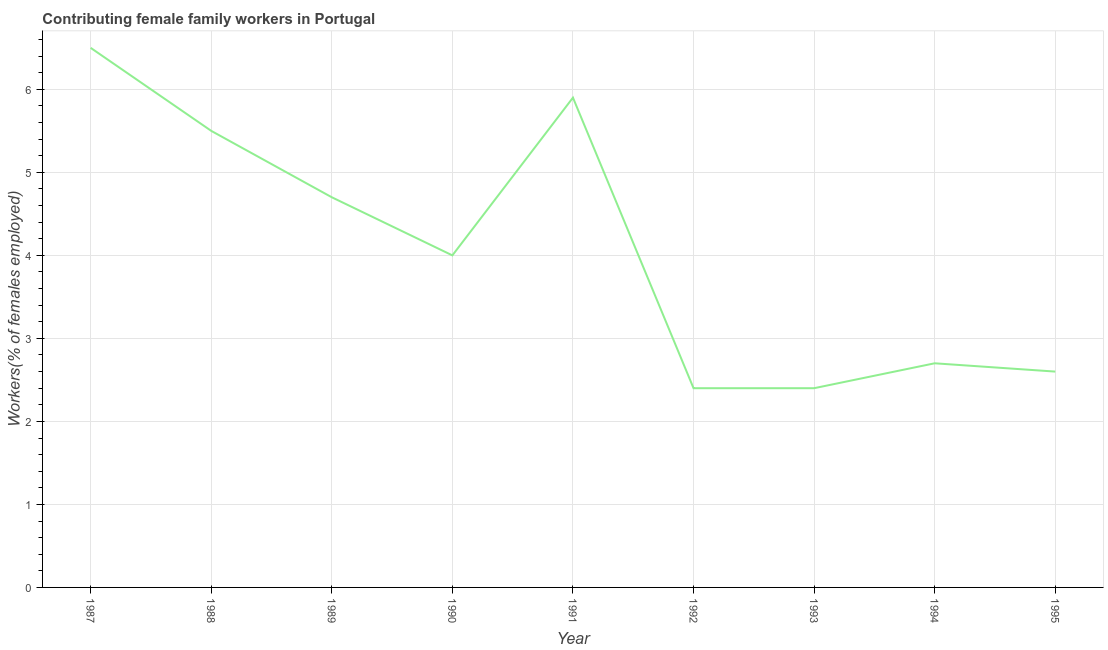What is the contributing female family workers in 1994?
Make the answer very short. 2.7. Across all years, what is the maximum contributing female family workers?
Provide a short and direct response. 6.5. Across all years, what is the minimum contributing female family workers?
Offer a very short reply. 2.4. What is the sum of the contributing female family workers?
Your response must be concise. 36.7. What is the difference between the contributing female family workers in 1987 and 1989?
Offer a very short reply. 1.8. What is the average contributing female family workers per year?
Give a very brief answer. 4.08. Do a majority of the years between 1987 and 1992 (inclusive) have contributing female family workers greater than 2.8 %?
Provide a short and direct response. Yes. What is the ratio of the contributing female family workers in 1990 to that in 1991?
Keep it short and to the point. 0.68. Is the contributing female family workers in 1994 less than that in 1995?
Make the answer very short. No. Is the difference between the contributing female family workers in 1989 and 1990 greater than the difference between any two years?
Your response must be concise. No. What is the difference between the highest and the second highest contributing female family workers?
Your answer should be very brief. 0.6. Is the sum of the contributing female family workers in 1993 and 1994 greater than the maximum contributing female family workers across all years?
Your response must be concise. No. What is the difference between the highest and the lowest contributing female family workers?
Provide a succinct answer. 4.1. In how many years, is the contributing female family workers greater than the average contributing female family workers taken over all years?
Your answer should be compact. 4. Does the contributing female family workers monotonically increase over the years?
Provide a short and direct response. No. How many lines are there?
Your response must be concise. 1. How many years are there in the graph?
Provide a succinct answer. 9. Does the graph contain grids?
Make the answer very short. Yes. What is the title of the graph?
Your response must be concise. Contributing female family workers in Portugal. What is the label or title of the X-axis?
Offer a terse response. Year. What is the label or title of the Y-axis?
Give a very brief answer. Workers(% of females employed). What is the Workers(% of females employed) in 1987?
Offer a very short reply. 6.5. What is the Workers(% of females employed) in 1989?
Your response must be concise. 4.7. What is the Workers(% of females employed) of 1990?
Provide a short and direct response. 4. What is the Workers(% of females employed) of 1991?
Provide a short and direct response. 5.9. What is the Workers(% of females employed) in 1992?
Make the answer very short. 2.4. What is the Workers(% of females employed) in 1993?
Ensure brevity in your answer.  2.4. What is the Workers(% of females employed) in 1994?
Offer a terse response. 2.7. What is the Workers(% of females employed) of 1995?
Provide a succinct answer. 2.6. What is the difference between the Workers(% of females employed) in 1987 and 1988?
Your answer should be very brief. 1. What is the difference between the Workers(% of females employed) in 1987 and 1989?
Your answer should be very brief. 1.8. What is the difference between the Workers(% of females employed) in 1987 and 1990?
Your answer should be very brief. 2.5. What is the difference between the Workers(% of females employed) in 1987 and 1991?
Offer a very short reply. 0.6. What is the difference between the Workers(% of females employed) in 1987 and 1993?
Keep it short and to the point. 4.1. What is the difference between the Workers(% of females employed) in 1987 and 1995?
Offer a terse response. 3.9. What is the difference between the Workers(% of females employed) in 1988 and 1989?
Your response must be concise. 0.8. What is the difference between the Workers(% of females employed) in 1988 and 1992?
Make the answer very short. 3.1. What is the difference between the Workers(% of females employed) in 1988 and 1995?
Your answer should be compact. 2.9. What is the difference between the Workers(% of females employed) in 1989 and 1991?
Provide a succinct answer. -1.2. What is the difference between the Workers(% of females employed) in 1989 and 1993?
Give a very brief answer. 2.3. What is the difference between the Workers(% of females employed) in 1989 and 1995?
Your answer should be compact. 2.1. What is the difference between the Workers(% of females employed) in 1990 and 1991?
Your response must be concise. -1.9. What is the difference between the Workers(% of females employed) in 1990 and 1993?
Keep it short and to the point. 1.6. What is the difference between the Workers(% of females employed) in 1991 and 1995?
Give a very brief answer. 3.3. What is the difference between the Workers(% of females employed) in 1992 and 1994?
Keep it short and to the point. -0.3. What is the difference between the Workers(% of females employed) in 1993 and 1995?
Your answer should be very brief. -0.2. What is the ratio of the Workers(% of females employed) in 1987 to that in 1988?
Make the answer very short. 1.18. What is the ratio of the Workers(% of females employed) in 1987 to that in 1989?
Offer a terse response. 1.38. What is the ratio of the Workers(% of females employed) in 1987 to that in 1990?
Make the answer very short. 1.62. What is the ratio of the Workers(% of females employed) in 1987 to that in 1991?
Provide a succinct answer. 1.1. What is the ratio of the Workers(% of females employed) in 1987 to that in 1992?
Offer a terse response. 2.71. What is the ratio of the Workers(% of females employed) in 1987 to that in 1993?
Your answer should be compact. 2.71. What is the ratio of the Workers(% of females employed) in 1987 to that in 1994?
Offer a very short reply. 2.41. What is the ratio of the Workers(% of females employed) in 1988 to that in 1989?
Your answer should be very brief. 1.17. What is the ratio of the Workers(% of females employed) in 1988 to that in 1990?
Your answer should be compact. 1.38. What is the ratio of the Workers(% of females employed) in 1988 to that in 1991?
Offer a terse response. 0.93. What is the ratio of the Workers(% of females employed) in 1988 to that in 1992?
Keep it short and to the point. 2.29. What is the ratio of the Workers(% of females employed) in 1988 to that in 1993?
Your answer should be very brief. 2.29. What is the ratio of the Workers(% of females employed) in 1988 to that in 1994?
Provide a short and direct response. 2.04. What is the ratio of the Workers(% of females employed) in 1988 to that in 1995?
Give a very brief answer. 2.12. What is the ratio of the Workers(% of females employed) in 1989 to that in 1990?
Your answer should be compact. 1.18. What is the ratio of the Workers(% of females employed) in 1989 to that in 1991?
Give a very brief answer. 0.8. What is the ratio of the Workers(% of females employed) in 1989 to that in 1992?
Your answer should be very brief. 1.96. What is the ratio of the Workers(% of females employed) in 1989 to that in 1993?
Make the answer very short. 1.96. What is the ratio of the Workers(% of females employed) in 1989 to that in 1994?
Your answer should be very brief. 1.74. What is the ratio of the Workers(% of females employed) in 1989 to that in 1995?
Offer a very short reply. 1.81. What is the ratio of the Workers(% of females employed) in 1990 to that in 1991?
Make the answer very short. 0.68. What is the ratio of the Workers(% of females employed) in 1990 to that in 1992?
Your answer should be very brief. 1.67. What is the ratio of the Workers(% of females employed) in 1990 to that in 1993?
Provide a succinct answer. 1.67. What is the ratio of the Workers(% of females employed) in 1990 to that in 1994?
Ensure brevity in your answer.  1.48. What is the ratio of the Workers(% of females employed) in 1990 to that in 1995?
Offer a terse response. 1.54. What is the ratio of the Workers(% of females employed) in 1991 to that in 1992?
Provide a succinct answer. 2.46. What is the ratio of the Workers(% of females employed) in 1991 to that in 1993?
Give a very brief answer. 2.46. What is the ratio of the Workers(% of females employed) in 1991 to that in 1994?
Ensure brevity in your answer.  2.19. What is the ratio of the Workers(% of females employed) in 1991 to that in 1995?
Your response must be concise. 2.27. What is the ratio of the Workers(% of females employed) in 1992 to that in 1993?
Your answer should be compact. 1. What is the ratio of the Workers(% of females employed) in 1992 to that in 1994?
Make the answer very short. 0.89. What is the ratio of the Workers(% of females employed) in 1992 to that in 1995?
Your answer should be very brief. 0.92. What is the ratio of the Workers(% of females employed) in 1993 to that in 1994?
Ensure brevity in your answer.  0.89. What is the ratio of the Workers(% of females employed) in 1993 to that in 1995?
Provide a short and direct response. 0.92. What is the ratio of the Workers(% of females employed) in 1994 to that in 1995?
Your answer should be very brief. 1.04. 